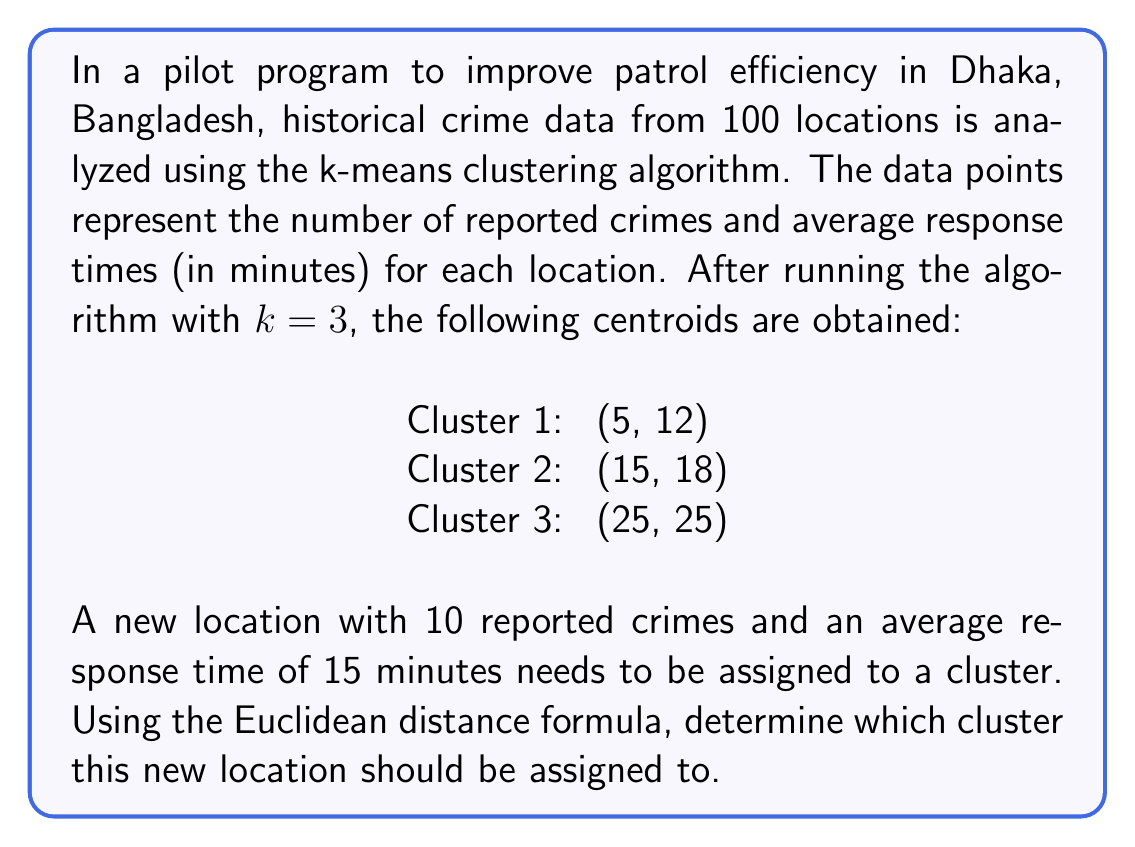Can you answer this question? To solve this problem, we need to follow these steps:

1. Understand the given data:
   - We have 3 cluster centroids: (5, 12), (15, 18), and (25, 25)
   - The new location has coordinates (10, 15)

2. Calculate the Euclidean distance between the new location and each centroid:
   The Euclidean distance formula in 2D space is:
   $$d = \sqrt{(x_2 - x_1)^2 + (y_2 - y_1)^2}$$

   Where $(x_1, y_1)$ is the new location and $(x_2, y_2)$ is the centroid.

3. For Cluster 1 (5, 12):
   $$d_1 = \sqrt{(5 - 10)^2 + (12 - 15)^2}$$
   $$d_1 = \sqrt{(-5)^2 + (-3)^2}$$
   $$d_1 = \sqrt{25 + 9}$$
   $$d_1 = \sqrt{34} \approx 5.83$$

4. For Cluster 2 (15, 18):
   $$d_2 = \sqrt{(15 - 10)^2 + (18 - 15)^2}$$
   $$d_2 = \sqrt{(5)^2 + (3)^2}$$
   $$d_2 = \sqrt{25 + 9}$$
   $$d_2 = \sqrt{34} \approx 5.83$$

5. For Cluster 3 (25, 25):
   $$d_3 = \sqrt{(25 - 10)^2 + (25 - 15)^2}$$
   $$d_3 = \sqrt{(15)^2 + (10)^2}$$
   $$d_3 = \sqrt{225 + 100}$$
   $$d_3 = \sqrt{325} \approx 18.03$$

6. Compare the distances:
   $d_1 \approx 5.83$
   $d_2 \approx 5.83$
   $d_3 \approx 18.03$

   The new location should be assigned to the cluster with the smallest distance. In this case, $d_1$ and $d_2$ are equal and smaller than $d_3$.

7. In case of a tie, we can choose either cluster. For consistency, we'll choose the cluster with the lower index.
Answer: The new location should be assigned to Cluster 1. 